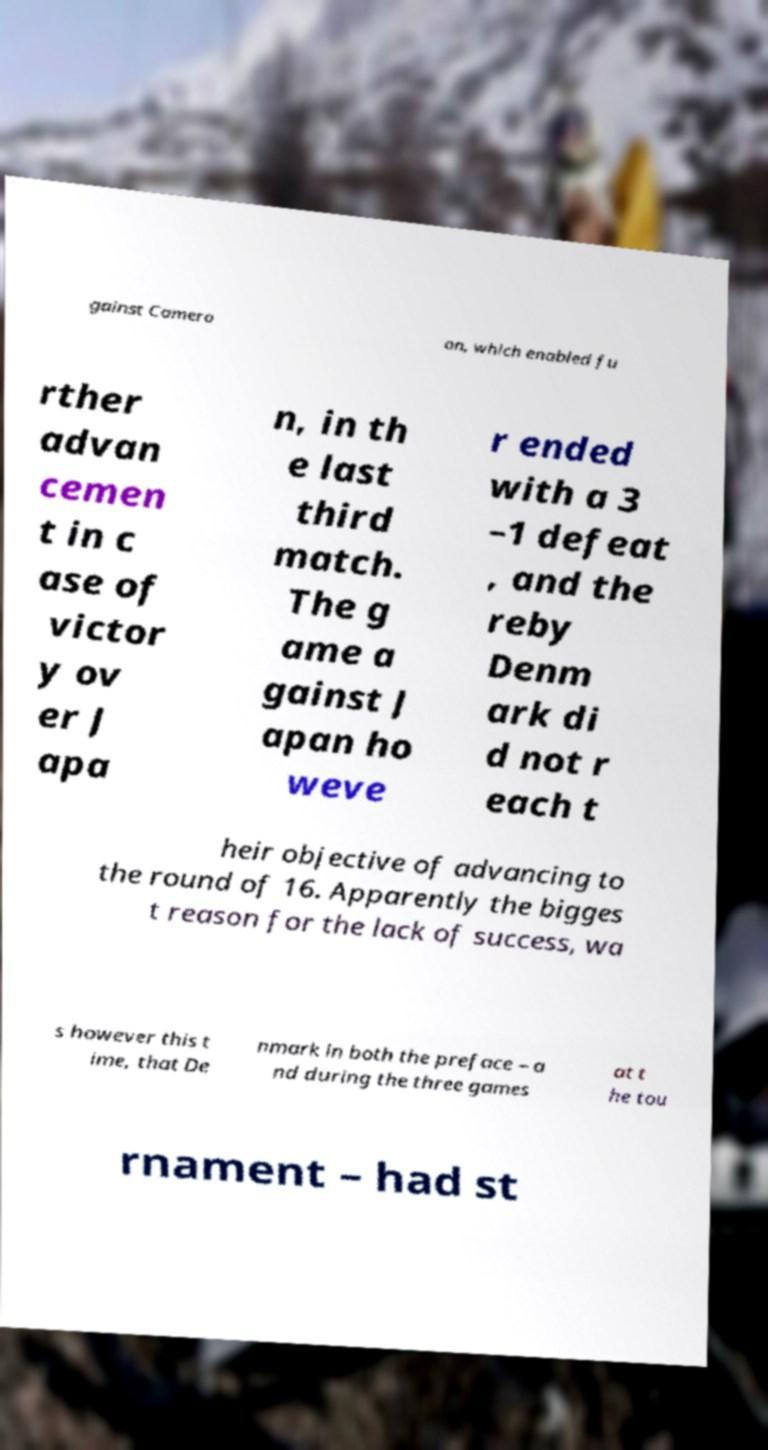Can you read and provide the text displayed in the image?This photo seems to have some interesting text. Can you extract and type it out for me? gainst Camero on, which enabled fu rther advan cemen t in c ase of victor y ov er J apa n, in th e last third match. The g ame a gainst J apan ho weve r ended with a 3 –1 defeat , and the reby Denm ark di d not r each t heir objective of advancing to the round of 16. Apparently the bigges t reason for the lack of success, wa s however this t ime, that De nmark in both the preface – a nd during the three games at t he tou rnament – had st 